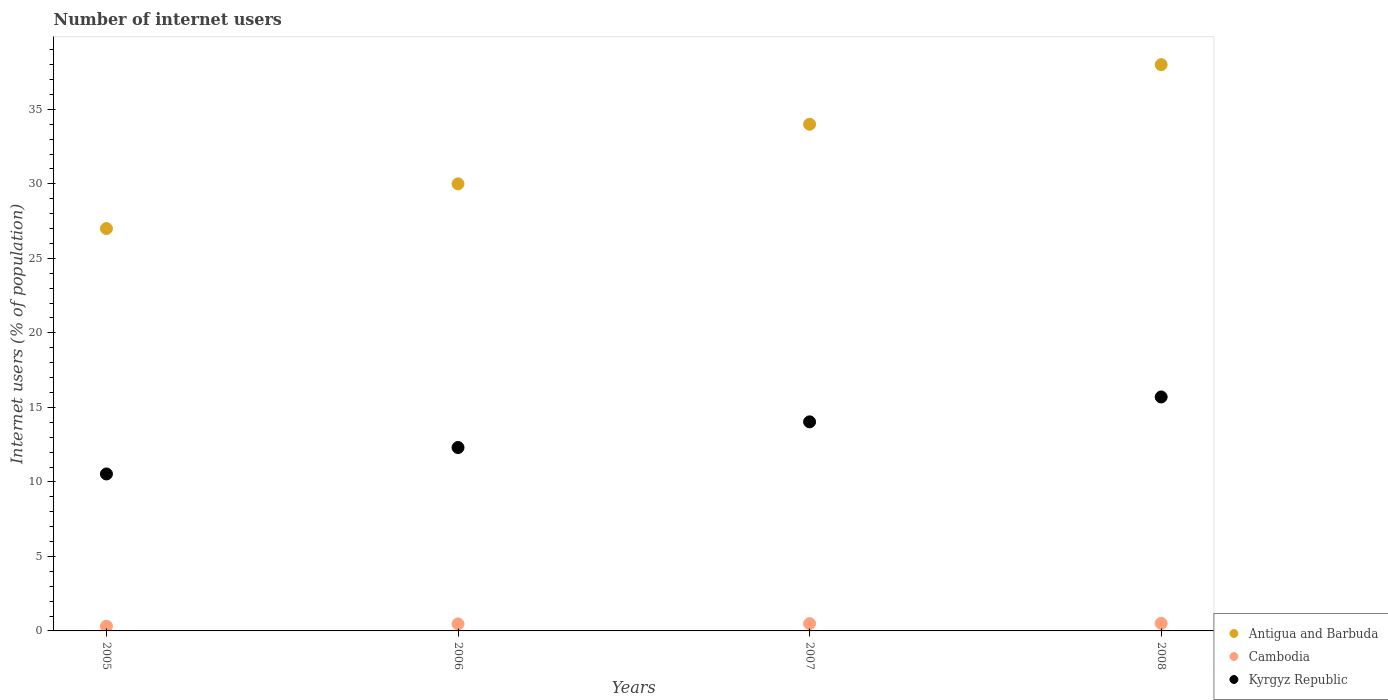Is the number of dotlines equal to the number of legend labels?
Give a very brief answer. Yes. Across all years, what is the minimum number of internet users in Cambodia?
Provide a short and direct response. 0.32. In which year was the number of internet users in Cambodia maximum?
Ensure brevity in your answer.  2008. What is the total number of internet users in Antigua and Barbuda in the graph?
Your answer should be compact. 129. What is the difference between the number of internet users in Kyrgyz Republic in 2005 and that in 2008?
Give a very brief answer. -5.17. What is the difference between the number of internet users in Kyrgyz Republic in 2007 and the number of internet users in Antigua and Barbuda in 2008?
Your response must be concise. -23.97. What is the average number of internet users in Kyrgyz Republic per year?
Offer a very short reply. 13.14. In the year 2008, what is the difference between the number of internet users in Cambodia and number of internet users in Antigua and Barbuda?
Offer a very short reply. -37.49. In how many years, is the number of internet users in Kyrgyz Republic greater than 36 %?
Your response must be concise. 0. What is the ratio of the number of internet users in Antigua and Barbuda in 2006 to that in 2008?
Keep it short and to the point. 0.79. Is the difference between the number of internet users in Cambodia in 2006 and 2008 greater than the difference between the number of internet users in Antigua and Barbuda in 2006 and 2008?
Keep it short and to the point. Yes. What is the difference between the highest and the second highest number of internet users in Kyrgyz Republic?
Offer a very short reply. 1.67. What is the difference between the highest and the lowest number of internet users in Kyrgyz Republic?
Provide a short and direct response. 5.17. In how many years, is the number of internet users in Cambodia greater than the average number of internet users in Cambodia taken over all years?
Provide a succinct answer. 3. Is the number of internet users in Cambodia strictly greater than the number of internet users in Kyrgyz Republic over the years?
Your answer should be very brief. No. Is the number of internet users in Antigua and Barbuda strictly less than the number of internet users in Kyrgyz Republic over the years?
Provide a succinct answer. No. How many dotlines are there?
Keep it short and to the point. 3. How many years are there in the graph?
Ensure brevity in your answer.  4. What is the difference between two consecutive major ticks on the Y-axis?
Your response must be concise. 5. Are the values on the major ticks of Y-axis written in scientific E-notation?
Provide a succinct answer. No. Does the graph contain any zero values?
Offer a very short reply. No. Does the graph contain grids?
Provide a short and direct response. No. How are the legend labels stacked?
Keep it short and to the point. Vertical. What is the title of the graph?
Give a very brief answer. Number of internet users. Does "Nigeria" appear as one of the legend labels in the graph?
Provide a short and direct response. No. What is the label or title of the X-axis?
Your answer should be compact. Years. What is the label or title of the Y-axis?
Give a very brief answer. Internet users (% of population). What is the Internet users (% of population) in Cambodia in 2005?
Your answer should be compact. 0.32. What is the Internet users (% of population) in Kyrgyz Republic in 2005?
Keep it short and to the point. 10.53. What is the Internet users (% of population) in Cambodia in 2006?
Ensure brevity in your answer.  0.47. What is the Internet users (% of population) in Kyrgyz Republic in 2006?
Offer a terse response. 12.31. What is the Internet users (% of population) in Cambodia in 2007?
Give a very brief answer. 0.49. What is the Internet users (% of population) in Kyrgyz Republic in 2007?
Your response must be concise. 14.03. What is the Internet users (% of population) in Cambodia in 2008?
Offer a very short reply. 0.51. Across all years, what is the maximum Internet users (% of population) of Cambodia?
Keep it short and to the point. 0.51. Across all years, what is the maximum Internet users (% of population) in Kyrgyz Republic?
Your answer should be very brief. 15.7. Across all years, what is the minimum Internet users (% of population) of Antigua and Barbuda?
Give a very brief answer. 27. Across all years, what is the minimum Internet users (% of population) of Cambodia?
Your response must be concise. 0.32. Across all years, what is the minimum Internet users (% of population) of Kyrgyz Republic?
Provide a short and direct response. 10.53. What is the total Internet users (% of population) in Antigua and Barbuda in the graph?
Give a very brief answer. 129. What is the total Internet users (% of population) of Cambodia in the graph?
Offer a terse response. 1.79. What is the total Internet users (% of population) in Kyrgyz Republic in the graph?
Keep it short and to the point. 52.57. What is the difference between the Internet users (% of population) of Cambodia in 2005 and that in 2006?
Offer a very short reply. -0.15. What is the difference between the Internet users (% of population) of Kyrgyz Republic in 2005 and that in 2006?
Offer a very short reply. -1.77. What is the difference between the Internet users (% of population) in Antigua and Barbuda in 2005 and that in 2007?
Keep it short and to the point. -7. What is the difference between the Internet users (% of population) of Cambodia in 2005 and that in 2007?
Provide a short and direct response. -0.17. What is the difference between the Internet users (% of population) in Kyrgyz Republic in 2005 and that in 2007?
Ensure brevity in your answer.  -3.5. What is the difference between the Internet users (% of population) in Cambodia in 2005 and that in 2008?
Offer a terse response. -0.19. What is the difference between the Internet users (% of population) in Kyrgyz Republic in 2005 and that in 2008?
Your response must be concise. -5.17. What is the difference between the Internet users (% of population) of Cambodia in 2006 and that in 2007?
Your answer should be very brief. -0.02. What is the difference between the Internet users (% of population) in Kyrgyz Republic in 2006 and that in 2007?
Offer a terse response. -1.72. What is the difference between the Internet users (% of population) in Cambodia in 2006 and that in 2008?
Offer a terse response. -0.04. What is the difference between the Internet users (% of population) of Kyrgyz Republic in 2006 and that in 2008?
Give a very brief answer. -3.39. What is the difference between the Internet users (% of population) of Antigua and Barbuda in 2007 and that in 2008?
Your answer should be very brief. -4. What is the difference between the Internet users (% of population) in Cambodia in 2007 and that in 2008?
Your answer should be very brief. -0.02. What is the difference between the Internet users (% of population) in Kyrgyz Republic in 2007 and that in 2008?
Ensure brevity in your answer.  -1.67. What is the difference between the Internet users (% of population) in Antigua and Barbuda in 2005 and the Internet users (% of population) in Cambodia in 2006?
Keep it short and to the point. 26.53. What is the difference between the Internet users (% of population) of Antigua and Barbuda in 2005 and the Internet users (% of population) of Kyrgyz Republic in 2006?
Ensure brevity in your answer.  14.69. What is the difference between the Internet users (% of population) in Cambodia in 2005 and the Internet users (% of population) in Kyrgyz Republic in 2006?
Your response must be concise. -11.99. What is the difference between the Internet users (% of population) in Antigua and Barbuda in 2005 and the Internet users (% of population) in Cambodia in 2007?
Provide a succinct answer. 26.51. What is the difference between the Internet users (% of population) in Antigua and Barbuda in 2005 and the Internet users (% of population) in Kyrgyz Republic in 2007?
Ensure brevity in your answer.  12.97. What is the difference between the Internet users (% of population) in Cambodia in 2005 and the Internet users (% of population) in Kyrgyz Republic in 2007?
Provide a short and direct response. -13.71. What is the difference between the Internet users (% of population) in Antigua and Barbuda in 2005 and the Internet users (% of population) in Cambodia in 2008?
Provide a succinct answer. 26.49. What is the difference between the Internet users (% of population) in Cambodia in 2005 and the Internet users (% of population) in Kyrgyz Republic in 2008?
Offer a very short reply. -15.38. What is the difference between the Internet users (% of population) in Antigua and Barbuda in 2006 and the Internet users (% of population) in Cambodia in 2007?
Provide a short and direct response. 29.51. What is the difference between the Internet users (% of population) in Antigua and Barbuda in 2006 and the Internet users (% of population) in Kyrgyz Republic in 2007?
Keep it short and to the point. 15.97. What is the difference between the Internet users (% of population) of Cambodia in 2006 and the Internet users (% of population) of Kyrgyz Republic in 2007?
Provide a succinct answer. -13.56. What is the difference between the Internet users (% of population) in Antigua and Barbuda in 2006 and the Internet users (% of population) in Cambodia in 2008?
Your response must be concise. 29.49. What is the difference between the Internet users (% of population) of Antigua and Barbuda in 2006 and the Internet users (% of population) of Kyrgyz Republic in 2008?
Your response must be concise. 14.3. What is the difference between the Internet users (% of population) of Cambodia in 2006 and the Internet users (% of population) of Kyrgyz Republic in 2008?
Give a very brief answer. -15.23. What is the difference between the Internet users (% of population) of Antigua and Barbuda in 2007 and the Internet users (% of population) of Cambodia in 2008?
Ensure brevity in your answer.  33.49. What is the difference between the Internet users (% of population) of Cambodia in 2007 and the Internet users (% of population) of Kyrgyz Republic in 2008?
Provide a succinct answer. -15.21. What is the average Internet users (% of population) of Antigua and Barbuda per year?
Give a very brief answer. 32.25. What is the average Internet users (% of population) of Cambodia per year?
Your answer should be compact. 0.45. What is the average Internet users (% of population) of Kyrgyz Republic per year?
Ensure brevity in your answer.  13.14. In the year 2005, what is the difference between the Internet users (% of population) in Antigua and Barbuda and Internet users (% of population) in Cambodia?
Offer a very short reply. 26.68. In the year 2005, what is the difference between the Internet users (% of population) in Antigua and Barbuda and Internet users (% of population) in Kyrgyz Republic?
Ensure brevity in your answer.  16.47. In the year 2005, what is the difference between the Internet users (% of population) in Cambodia and Internet users (% of population) in Kyrgyz Republic?
Offer a terse response. -10.22. In the year 2006, what is the difference between the Internet users (% of population) of Antigua and Barbuda and Internet users (% of population) of Cambodia?
Provide a succinct answer. 29.53. In the year 2006, what is the difference between the Internet users (% of population) of Antigua and Barbuda and Internet users (% of population) of Kyrgyz Republic?
Give a very brief answer. 17.69. In the year 2006, what is the difference between the Internet users (% of population) of Cambodia and Internet users (% of population) of Kyrgyz Republic?
Offer a terse response. -11.84. In the year 2007, what is the difference between the Internet users (% of population) in Antigua and Barbuda and Internet users (% of population) in Cambodia?
Your answer should be very brief. 33.51. In the year 2007, what is the difference between the Internet users (% of population) in Antigua and Barbuda and Internet users (% of population) in Kyrgyz Republic?
Provide a succinct answer. 19.97. In the year 2007, what is the difference between the Internet users (% of population) of Cambodia and Internet users (% of population) of Kyrgyz Republic?
Give a very brief answer. -13.54. In the year 2008, what is the difference between the Internet users (% of population) of Antigua and Barbuda and Internet users (% of population) of Cambodia?
Ensure brevity in your answer.  37.49. In the year 2008, what is the difference between the Internet users (% of population) in Antigua and Barbuda and Internet users (% of population) in Kyrgyz Republic?
Your response must be concise. 22.3. In the year 2008, what is the difference between the Internet users (% of population) of Cambodia and Internet users (% of population) of Kyrgyz Republic?
Offer a very short reply. -15.19. What is the ratio of the Internet users (% of population) in Antigua and Barbuda in 2005 to that in 2006?
Ensure brevity in your answer.  0.9. What is the ratio of the Internet users (% of population) in Cambodia in 2005 to that in 2006?
Ensure brevity in your answer.  0.68. What is the ratio of the Internet users (% of population) in Kyrgyz Republic in 2005 to that in 2006?
Your response must be concise. 0.86. What is the ratio of the Internet users (% of population) of Antigua and Barbuda in 2005 to that in 2007?
Offer a terse response. 0.79. What is the ratio of the Internet users (% of population) of Cambodia in 2005 to that in 2007?
Offer a terse response. 0.65. What is the ratio of the Internet users (% of population) of Kyrgyz Republic in 2005 to that in 2007?
Provide a succinct answer. 0.75. What is the ratio of the Internet users (% of population) in Antigua and Barbuda in 2005 to that in 2008?
Provide a short and direct response. 0.71. What is the ratio of the Internet users (% of population) in Cambodia in 2005 to that in 2008?
Your answer should be very brief. 0.62. What is the ratio of the Internet users (% of population) in Kyrgyz Republic in 2005 to that in 2008?
Your answer should be very brief. 0.67. What is the ratio of the Internet users (% of population) in Antigua and Barbuda in 2006 to that in 2007?
Give a very brief answer. 0.88. What is the ratio of the Internet users (% of population) in Cambodia in 2006 to that in 2007?
Offer a very short reply. 0.96. What is the ratio of the Internet users (% of population) in Kyrgyz Republic in 2006 to that in 2007?
Offer a very short reply. 0.88. What is the ratio of the Internet users (% of population) of Antigua and Barbuda in 2006 to that in 2008?
Offer a terse response. 0.79. What is the ratio of the Internet users (% of population) in Cambodia in 2006 to that in 2008?
Ensure brevity in your answer.  0.92. What is the ratio of the Internet users (% of population) in Kyrgyz Republic in 2006 to that in 2008?
Give a very brief answer. 0.78. What is the ratio of the Internet users (% of population) in Antigua and Barbuda in 2007 to that in 2008?
Give a very brief answer. 0.89. What is the ratio of the Internet users (% of population) of Cambodia in 2007 to that in 2008?
Your response must be concise. 0.96. What is the ratio of the Internet users (% of population) in Kyrgyz Republic in 2007 to that in 2008?
Your answer should be compact. 0.89. What is the difference between the highest and the second highest Internet users (% of population) in Antigua and Barbuda?
Ensure brevity in your answer.  4. What is the difference between the highest and the second highest Internet users (% of population) of Cambodia?
Your response must be concise. 0.02. What is the difference between the highest and the second highest Internet users (% of population) of Kyrgyz Republic?
Provide a short and direct response. 1.67. What is the difference between the highest and the lowest Internet users (% of population) in Cambodia?
Ensure brevity in your answer.  0.19. What is the difference between the highest and the lowest Internet users (% of population) in Kyrgyz Republic?
Give a very brief answer. 5.17. 